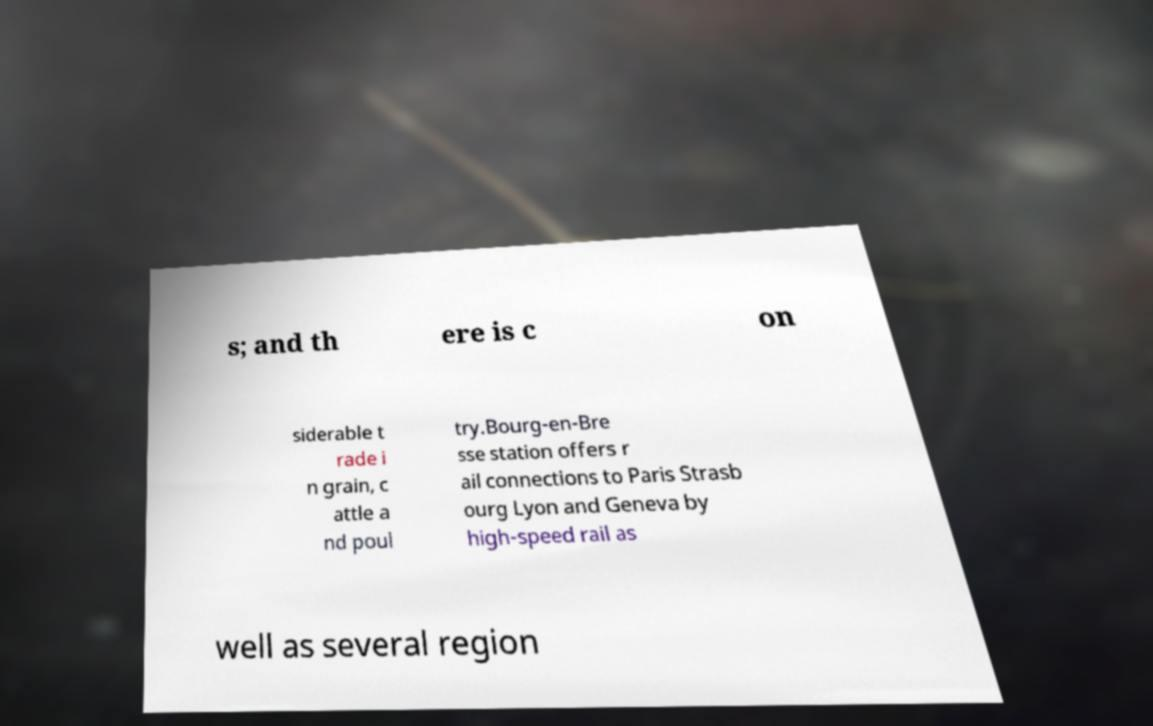Please read and relay the text visible in this image. What does it say? s; and th ere is c on siderable t rade i n grain, c attle a nd poul try.Bourg-en-Bre sse station offers r ail connections to Paris Strasb ourg Lyon and Geneva by high-speed rail as well as several region 